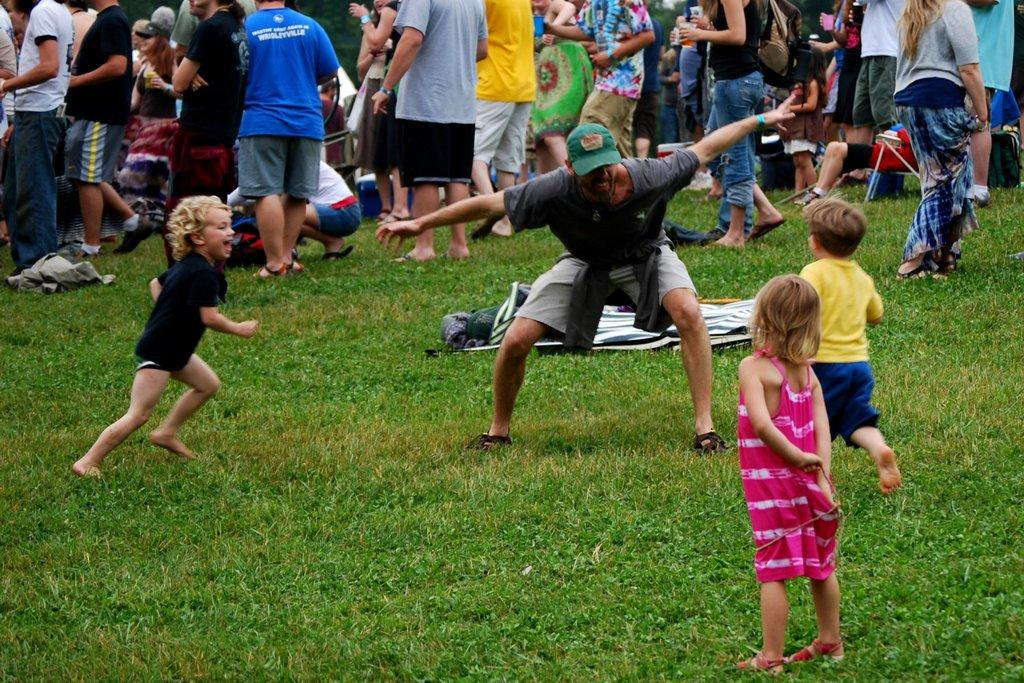How many children are in the image? There are 3 children in the image. Who else is present in the image besides the children? There is a man in the image. What are the man and children doing in the image? The man and children are standing. What type of surface are they standing on? There is grass visible in the image, so they are likely standing on grass. Can you describe the background of the image? There are people in the background of the image. Can you see a rabbit or a monkey in the image? No, there is no rabbit or monkey present in the image. 